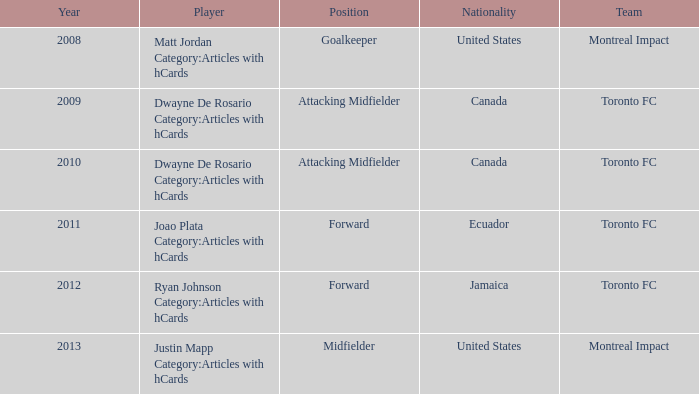What's the position when the player was Justin Mapp Category:articles with hcards with a United States nationality? Midfielder. 